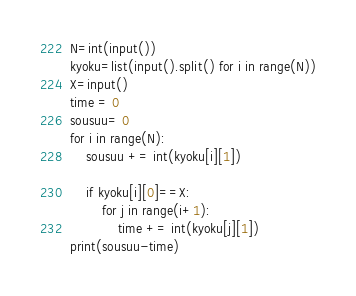Convert code to text. <code><loc_0><loc_0><loc_500><loc_500><_Python_>N=int(input())
kyoku=list(input().split() for i in range(N))
X=input()
time = 0
sousuu= 0
for i in range(N):
    sousuu += int(kyoku[i][1])

    if kyoku[i][0]==X:
        for j in range(i+1):
            time += int(kyoku[j][1])
print(sousuu-time)</code> 